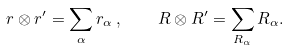<formula> <loc_0><loc_0><loc_500><loc_500>r \otimes r ^ { \prime } = \sum _ { \alpha } r _ { \alpha } \, , \quad R \otimes R ^ { \prime } = \sum _ { R _ { \alpha } } R _ { \alpha } .</formula> 